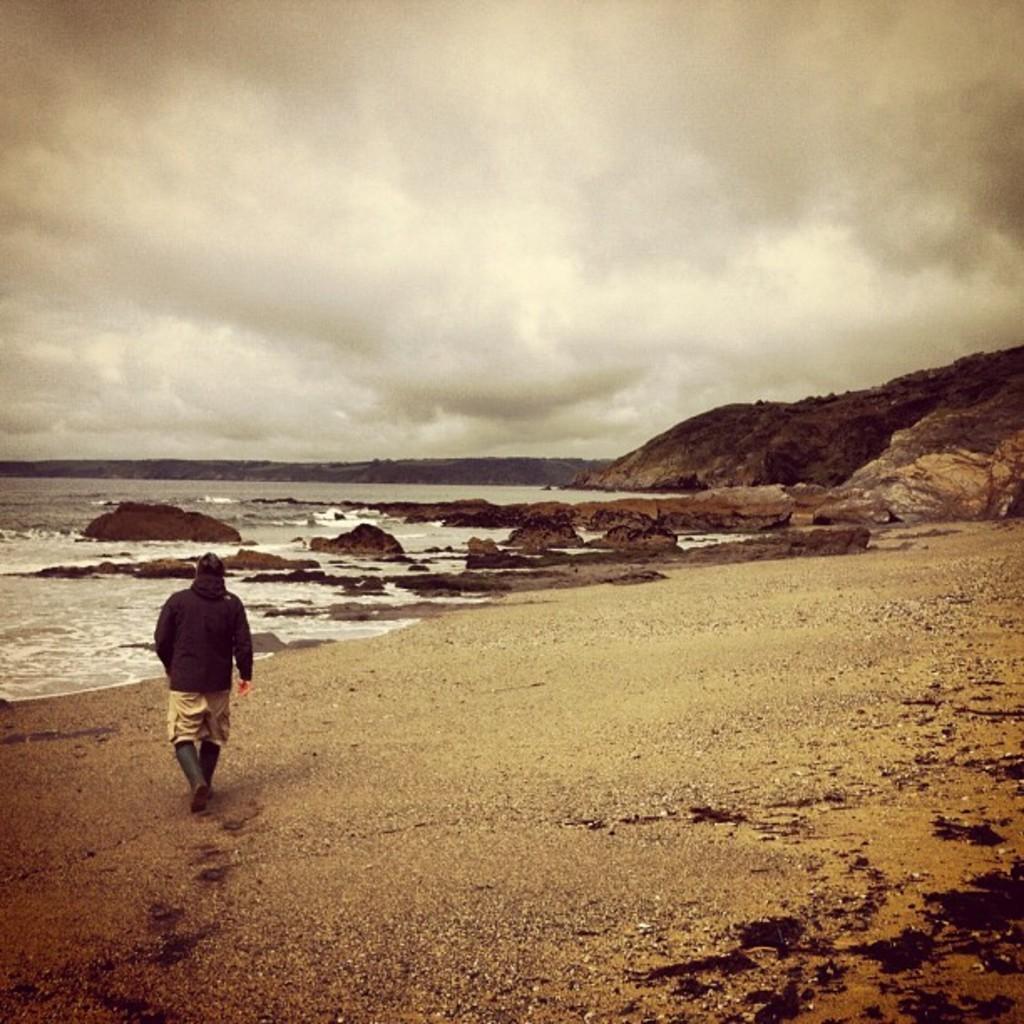How would you summarize this image in a sentence or two? This image consists of a person walking. At the bottom, there is sand. To the left, there is a beach. To the right, there are mountains. At the top, there are clouds in the sky. 